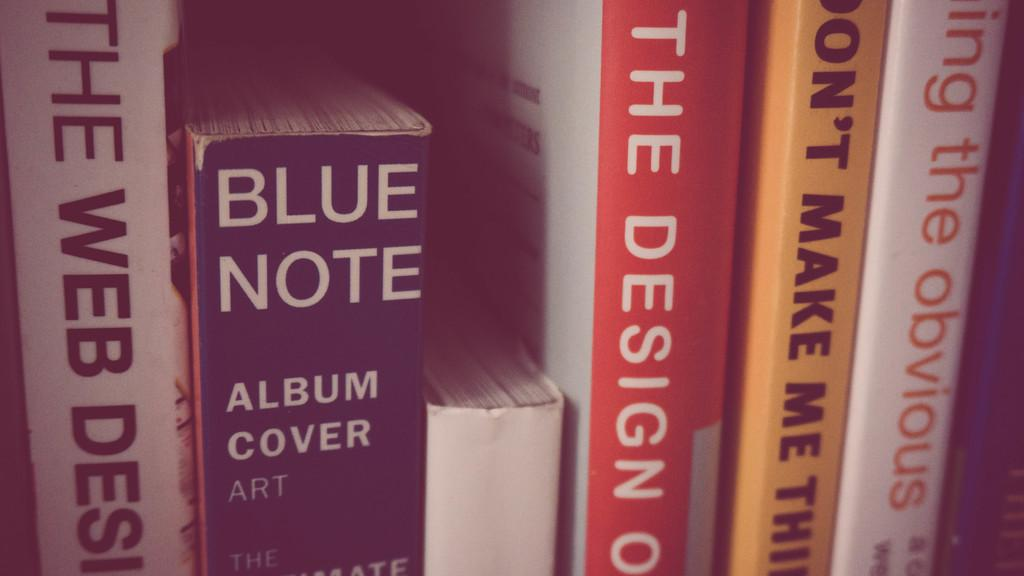Provide a one-sentence caption for the provided image. Blue Note is a very thick book about album cover art. 